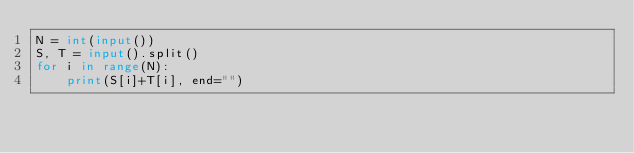<code> <loc_0><loc_0><loc_500><loc_500><_Python_>N = int(input())
S, T = input().split()
for i in range(N):
    print(S[i]+T[i], end="")
</code> 